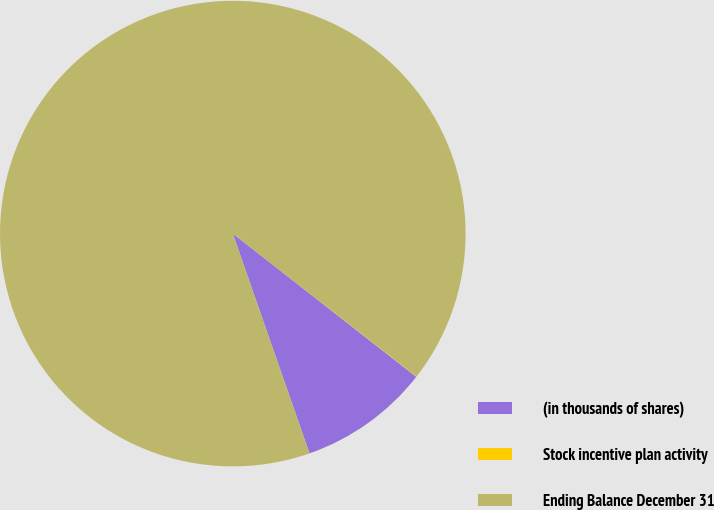<chart> <loc_0><loc_0><loc_500><loc_500><pie_chart><fcel>(in thousands of shares)<fcel>Stock incentive plan activity<fcel>Ending Balance December 31<nl><fcel>9.11%<fcel>0.03%<fcel>90.86%<nl></chart> 